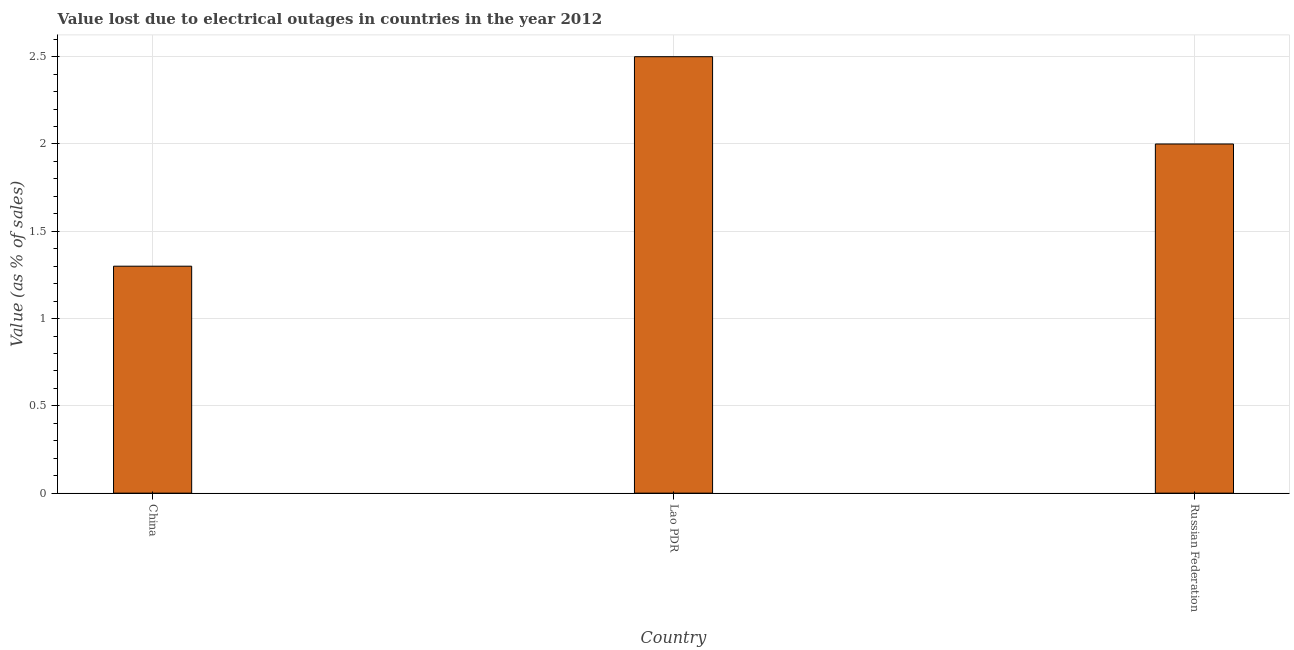Does the graph contain grids?
Ensure brevity in your answer.  Yes. What is the title of the graph?
Your answer should be very brief. Value lost due to electrical outages in countries in the year 2012. What is the label or title of the X-axis?
Your response must be concise. Country. What is the label or title of the Y-axis?
Keep it short and to the point. Value (as % of sales). Across all countries, what is the maximum value lost due to electrical outages?
Your response must be concise. 2.5. In which country was the value lost due to electrical outages maximum?
Ensure brevity in your answer.  Lao PDR. In which country was the value lost due to electrical outages minimum?
Give a very brief answer. China. What is the sum of the value lost due to electrical outages?
Provide a short and direct response. 5.8. What is the average value lost due to electrical outages per country?
Give a very brief answer. 1.93. In how many countries, is the value lost due to electrical outages greater than 0.8 %?
Your response must be concise. 3. What is the ratio of the value lost due to electrical outages in China to that in Russian Federation?
Give a very brief answer. 0.65. What is the difference between the highest and the second highest value lost due to electrical outages?
Provide a succinct answer. 0.5. Is the sum of the value lost due to electrical outages in Lao PDR and Russian Federation greater than the maximum value lost due to electrical outages across all countries?
Give a very brief answer. Yes. What is the difference between the highest and the lowest value lost due to electrical outages?
Your answer should be very brief. 1.2. How many bars are there?
Your answer should be very brief. 3. Are all the bars in the graph horizontal?
Provide a succinct answer. No. How many countries are there in the graph?
Offer a terse response. 3. What is the Value (as % of sales) of China?
Make the answer very short. 1.3. What is the Value (as % of sales) in Russian Federation?
Your answer should be compact. 2. What is the difference between the Value (as % of sales) in China and Lao PDR?
Your response must be concise. -1.2. What is the difference between the Value (as % of sales) in China and Russian Federation?
Your answer should be compact. -0.7. What is the difference between the Value (as % of sales) in Lao PDR and Russian Federation?
Your response must be concise. 0.5. What is the ratio of the Value (as % of sales) in China to that in Lao PDR?
Your answer should be compact. 0.52. What is the ratio of the Value (as % of sales) in China to that in Russian Federation?
Offer a terse response. 0.65. What is the ratio of the Value (as % of sales) in Lao PDR to that in Russian Federation?
Your answer should be compact. 1.25. 